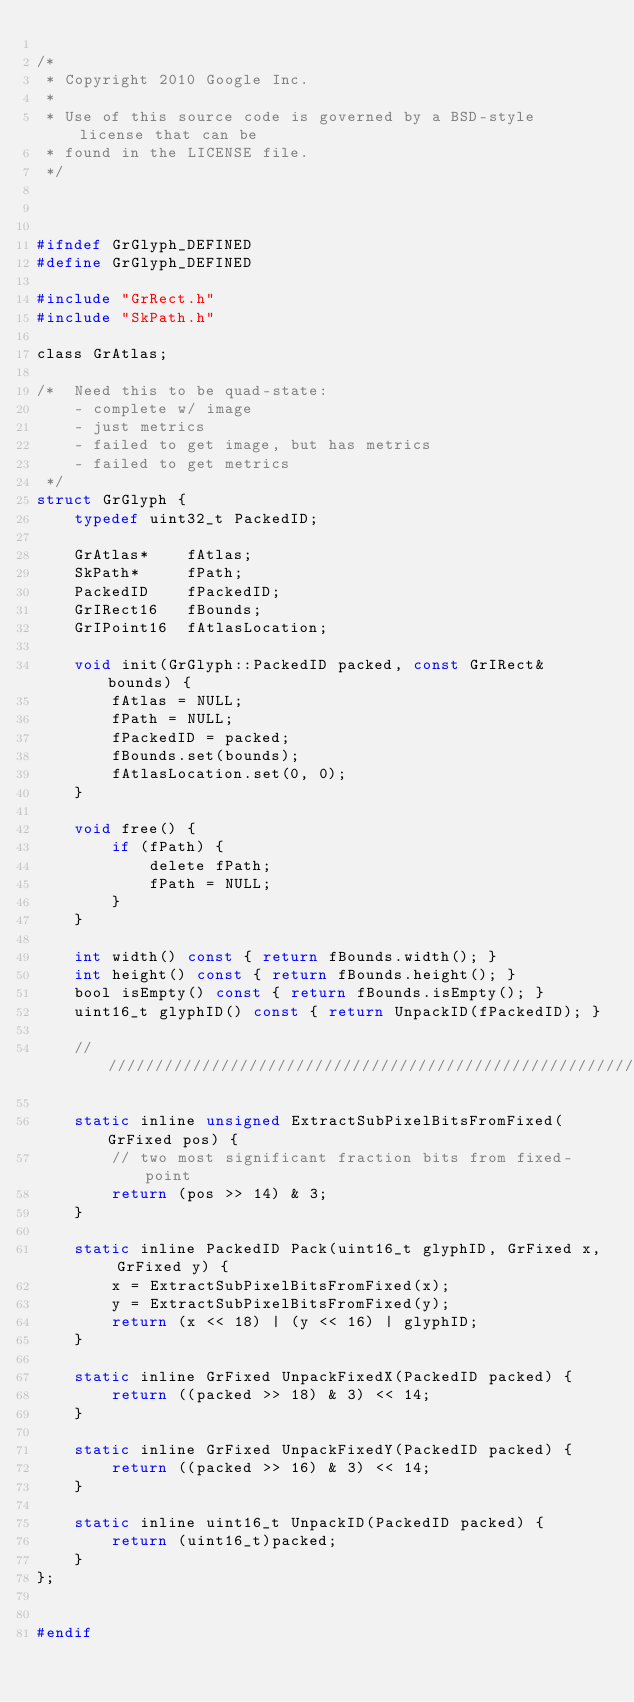<code> <loc_0><loc_0><loc_500><loc_500><_C_>
/*
 * Copyright 2010 Google Inc.
 *
 * Use of this source code is governed by a BSD-style license that can be
 * found in the LICENSE file.
 */



#ifndef GrGlyph_DEFINED
#define GrGlyph_DEFINED

#include "GrRect.h"
#include "SkPath.h"

class GrAtlas;

/*  Need this to be quad-state:
    - complete w/ image
    - just metrics
    - failed to get image, but has metrics
    - failed to get metrics
 */
struct GrGlyph {
    typedef uint32_t PackedID;

    GrAtlas*    fAtlas;
    SkPath*     fPath;
    PackedID    fPackedID;
    GrIRect16   fBounds;
    GrIPoint16  fAtlasLocation;

    void init(GrGlyph::PackedID packed, const GrIRect& bounds) {
        fAtlas = NULL;
        fPath = NULL;
        fPackedID = packed;
        fBounds.set(bounds);
        fAtlasLocation.set(0, 0);
    }
    
    void free() {
        if (fPath) {
            delete fPath;
            fPath = NULL;
        }
    }
    
    int width() const { return fBounds.width(); }
    int height() const { return fBounds.height(); }
    bool isEmpty() const { return fBounds.isEmpty(); }
    uint16_t glyphID() const { return UnpackID(fPackedID); }

    ///////////////////////////////////////////////////////////////////////////
    
    static inline unsigned ExtractSubPixelBitsFromFixed(GrFixed pos) {
        // two most significant fraction bits from fixed-point
        return (pos >> 14) & 3;
    }
    
    static inline PackedID Pack(uint16_t glyphID, GrFixed x, GrFixed y) {
        x = ExtractSubPixelBitsFromFixed(x);
        y = ExtractSubPixelBitsFromFixed(y);
        return (x << 18) | (y << 16) | glyphID;
    }
    
    static inline GrFixed UnpackFixedX(PackedID packed) {
        return ((packed >> 18) & 3) << 14;
    }
    
    static inline GrFixed UnpackFixedY(PackedID packed) {
        return ((packed >> 16) & 3) << 14;
    }
    
    static inline uint16_t UnpackID(PackedID packed) {
        return (uint16_t)packed;
    }
};


#endif

</code> 